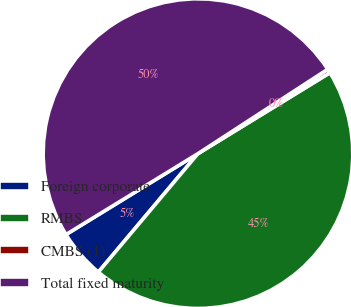Convert chart. <chart><loc_0><loc_0><loc_500><loc_500><pie_chart><fcel>Foreign corporate<fcel>RMBS<fcel>CMBS (1)<fcel>Total fixed maturity<nl><fcel>5.12%<fcel>44.88%<fcel>0.42%<fcel>49.58%<nl></chart> 